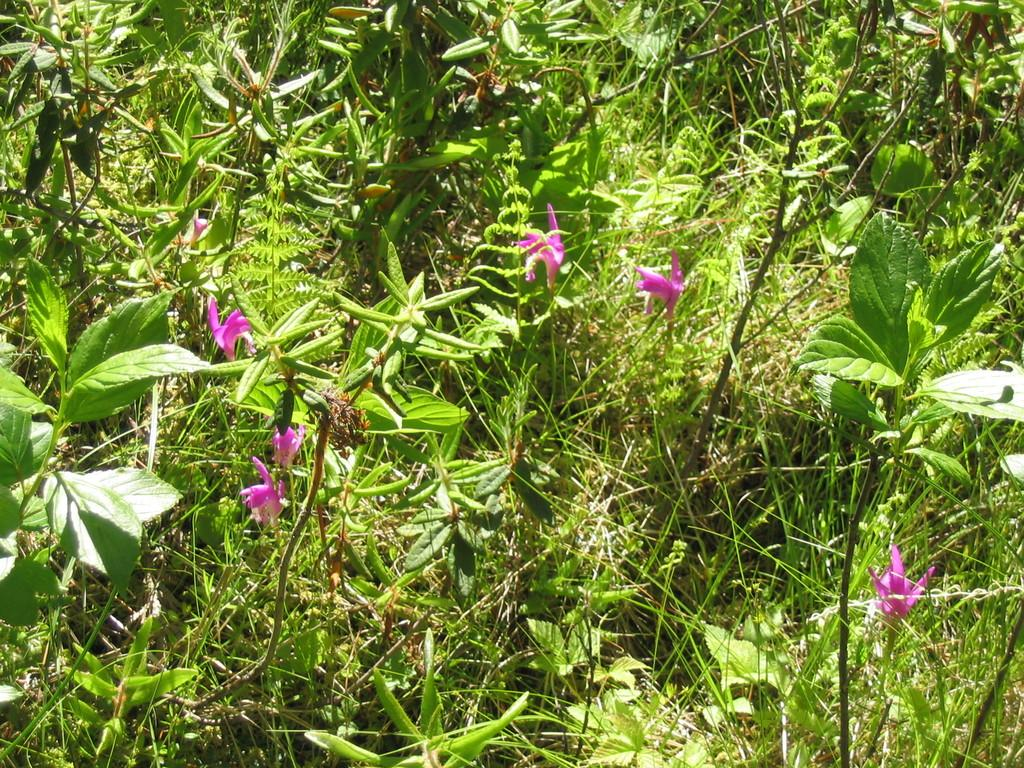What type of plants can be seen in the image? There are plants with flowers in the image. What is visible behind the flowers? There is grass visible behind the flowers. What type of pest can be seen crawling on the flowers in the image? There is no pest visible on the flowers in the image. What type of snack is being served alongside the flowers in the image? There is no snack, such as popcorn, present in the image. 